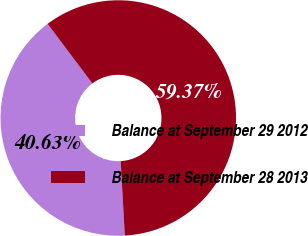Convert chart to OTSL. <chart><loc_0><loc_0><loc_500><loc_500><pie_chart><fcel>Balance at September 29 2012<fcel>Balance at September 28 2013<nl><fcel>40.63%<fcel>59.37%<nl></chart> 